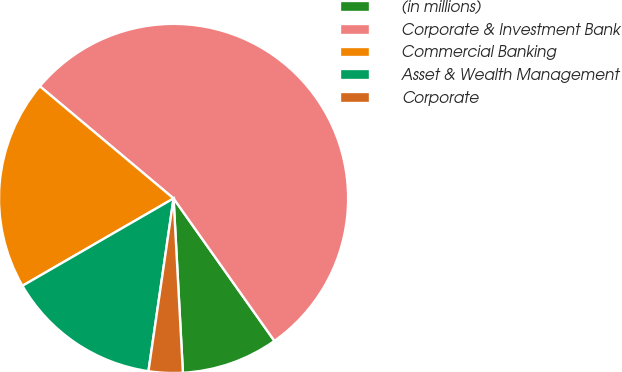Convert chart. <chart><loc_0><loc_0><loc_500><loc_500><pie_chart><fcel>(in millions)<fcel>Corporate & Investment Bank<fcel>Commercial Banking<fcel>Asset & Wealth Management<fcel>Corporate<nl><fcel>8.95%<fcel>54.09%<fcel>19.45%<fcel>14.36%<fcel>3.15%<nl></chart> 